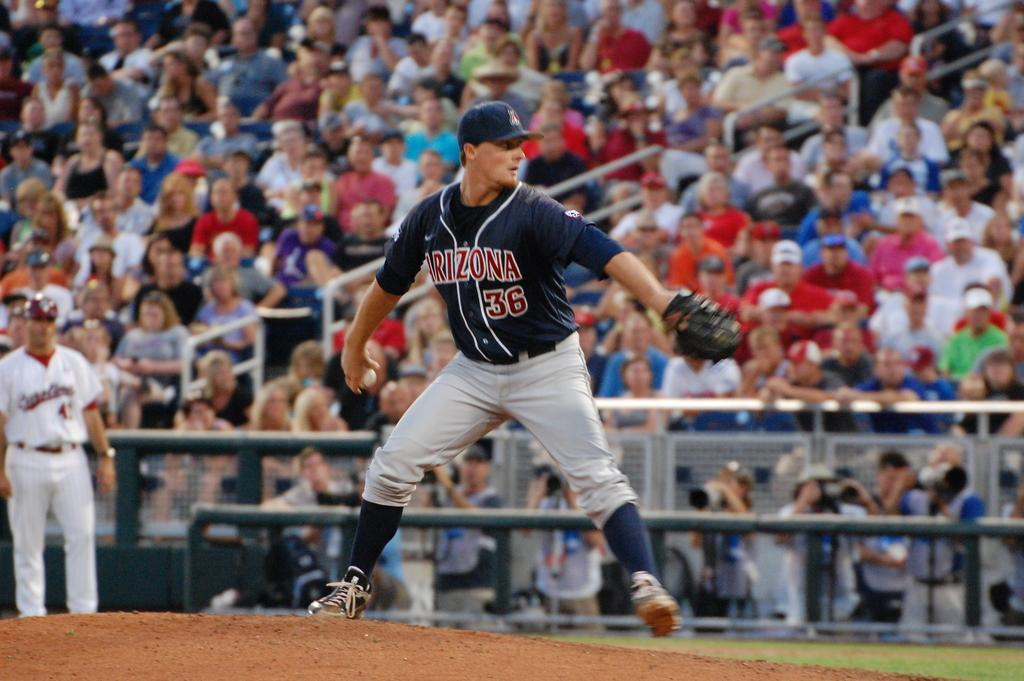<image>
Present a compact description of the photo's key features. Arizona's number 36 pitches a ball during a game. 